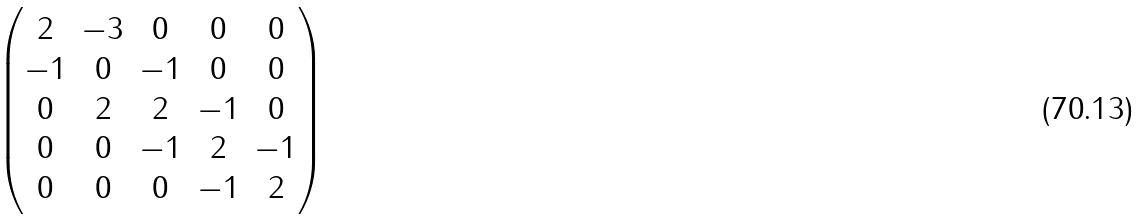<formula> <loc_0><loc_0><loc_500><loc_500>\begin{pmatrix} 2 & - 3 & 0 & 0 & 0 \\ - 1 & 0 & - 1 & 0 & 0 \\ 0 & 2 & 2 & - 1 & 0 \\ 0 & 0 & - 1 & 2 & - 1 \\ 0 & 0 & 0 & - 1 & 2 \end{pmatrix}</formula> 